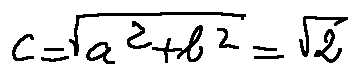<formula> <loc_0><loc_0><loc_500><loc_500>c = \sqrt { a ^ { 2 } + b ^ { 2 } } = \sqrt { 2 }</formula> 